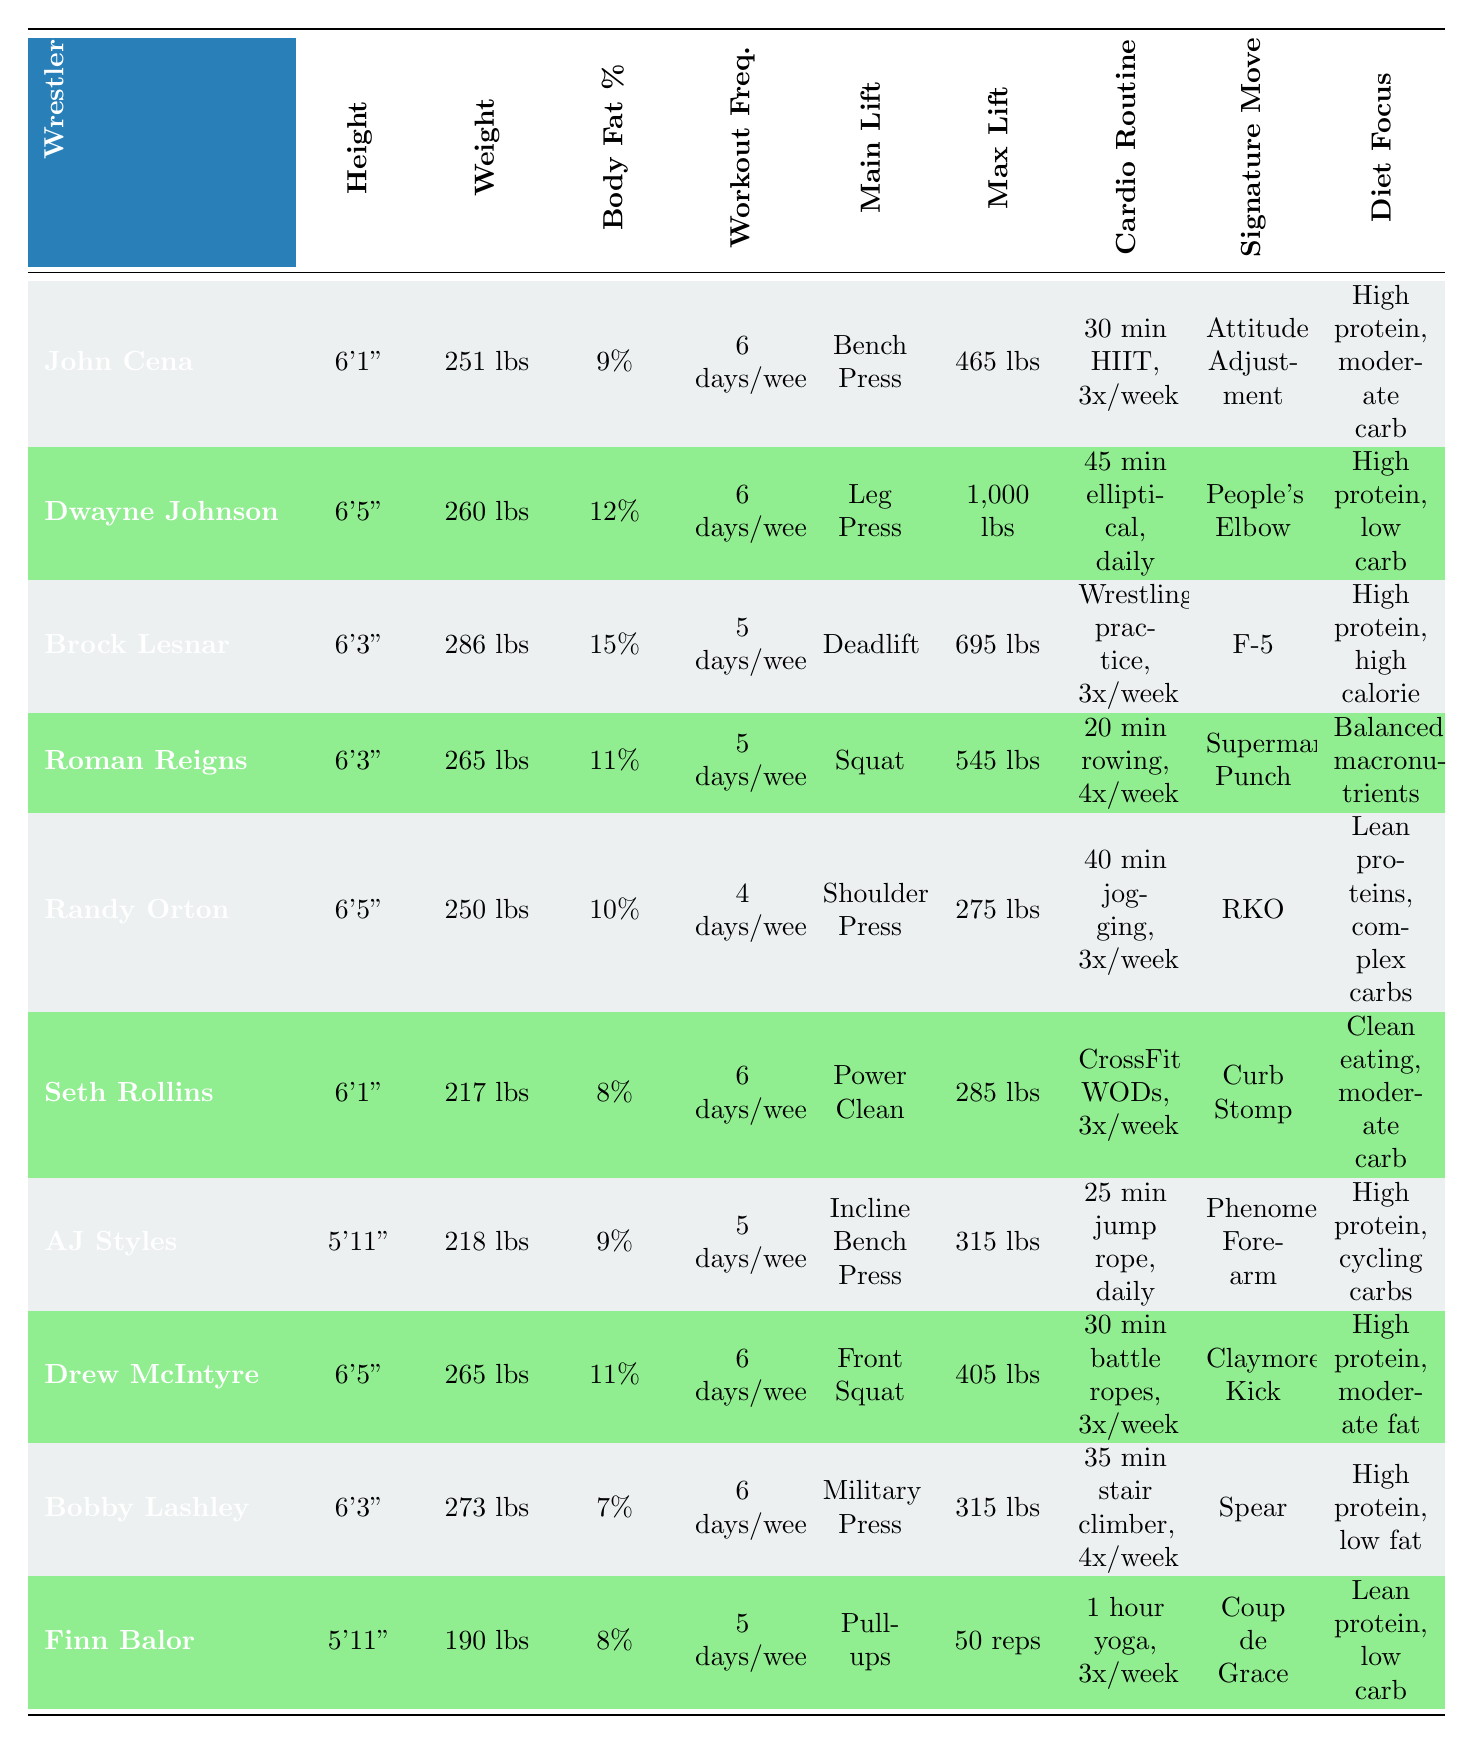What is the heaviest wrestler listed in the table? By reviewing the weight column, Brock Lesnar has the highest weight at 286 lbs compared to others.
Answer: 286 lbs Which wrestler has the lowest body fat percentage? Looking at the body fat percentage column, Bobby Lashley has the lowest body fat at 7%.
Answer: 7% How many days a week does John Cena work out compared to Randy Orton? John Cena works out 6 days a week, while Randy Orton works out 4 days a week; thus, John Cena works out 2 more days than Randy Orton.
Answer: 2 more days What is the average maximum bench press of the wrestlers listed? The listed maximum bench presses are: 465, 1000, 695, 545, 275, 285, 315, 405, 315, and 0 (for pull-ups). Adding these values gives a total of 3960 lbs. Dividing by 9 (the number of wrestlers with a specified lift except pull-ups) results in an average of 440 lbs.
Answer: 440 lbs Is Roman Reigns taller than Dwayne Johnson? Roman Reigns stands at 6'3" and Dwayne Johnson at 6'5". Therefore, Roman Reigns is not taller than Dwayne Johnson.
Answer: No Which wrestler performs cardio 3 times a week and also has a diet focusing on moderate fat? Drew McIntyre does cardio (30 min battle ropes) 3 times a week and focuses on high protein and moderate fat in his diet.
Answer: Drew McIntyre What is the difference in weight between Finn Balor and AJ Styles? Finn Balor weighs 190 lbs and AJ Styles weighs 218 lbs. The difference is 218 - 190 = 28 lbs.
Answer: 28 lbs What is the main lift of the wrestler with the highest body fat percentage? Brock Lesnar has the highest body fat percentage at 15%, and his main lift is the Deadlift.
Answer: Deadlift How many wrestlers work out 6 days a week? The wrestlers who work out 6 days a week are John Cena, Dwayne Johnson, Seth Rollins, Drew McIntyre, and Bobby Lashley, totaling 5 wrestlers.
Answer: 5 wrestlers 